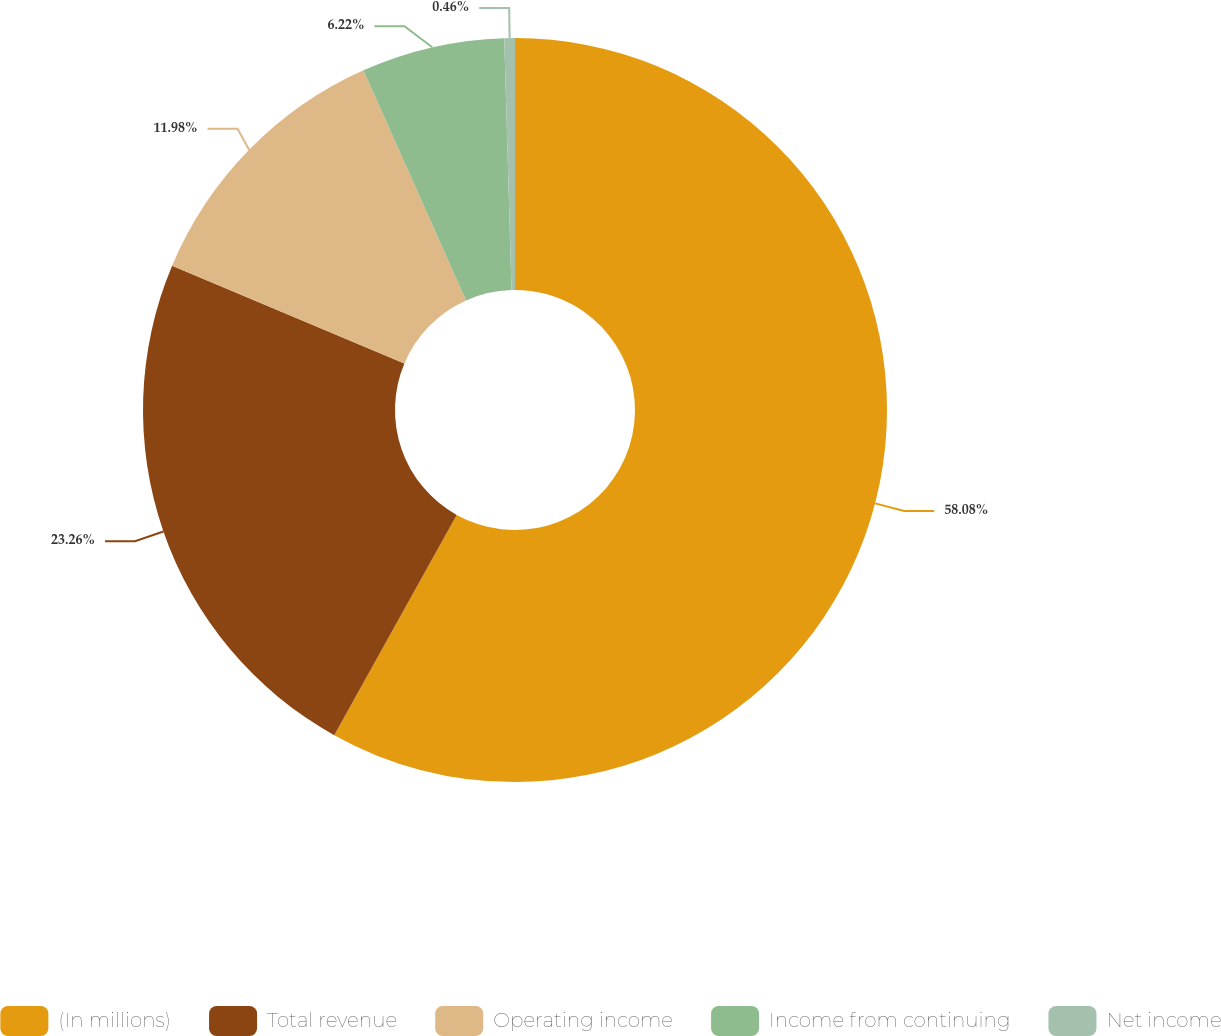<chart> <loc_0><loc_0><loc_500><loc_500><pie_chart><fcel>(In millions)<fcel>Total revenue<fcel>Operating income<fcel>Income from continuing<fcel>Net income<nl><fcel>58.07%<fcel>23.26%<fcel>11.98%<fcel>6.22%<fcel>0.46%<nl></chart> 